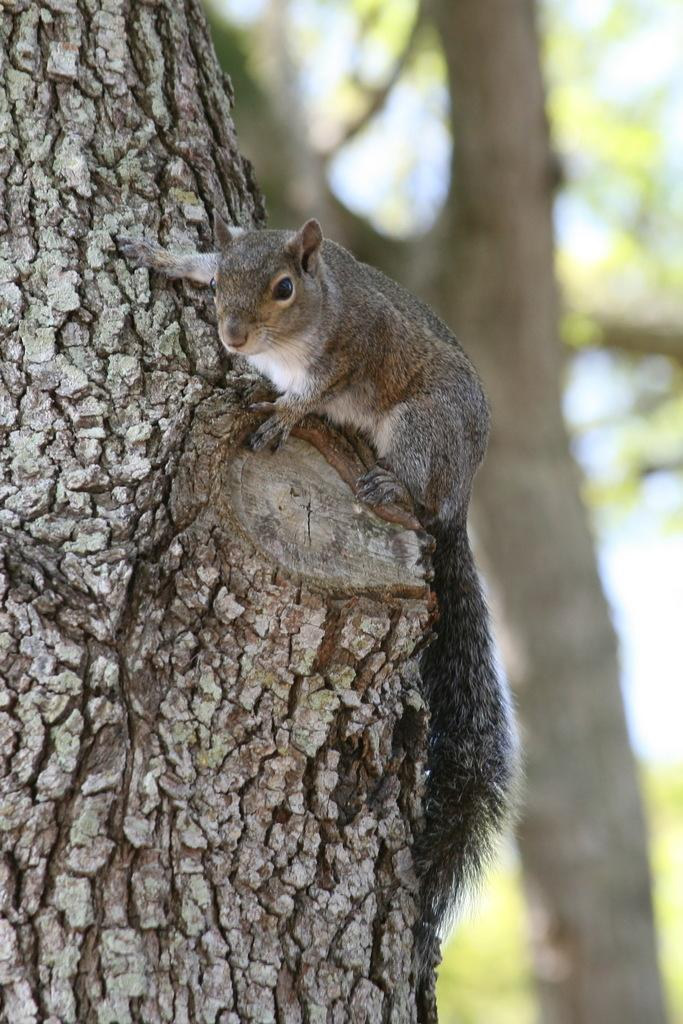What is the overall appearance of the background in the image? The background portion of the picture is blurry. What can be seen in the foreground of the image? There is a tree trunk in the image. What type of animal is present in the image? There is a squirrel on a branch in the image. What type of sound can be heard coming from the tree trunk in the image? There is no sound present in the image, so it cannot be determined what, if any, sound might be heard. 